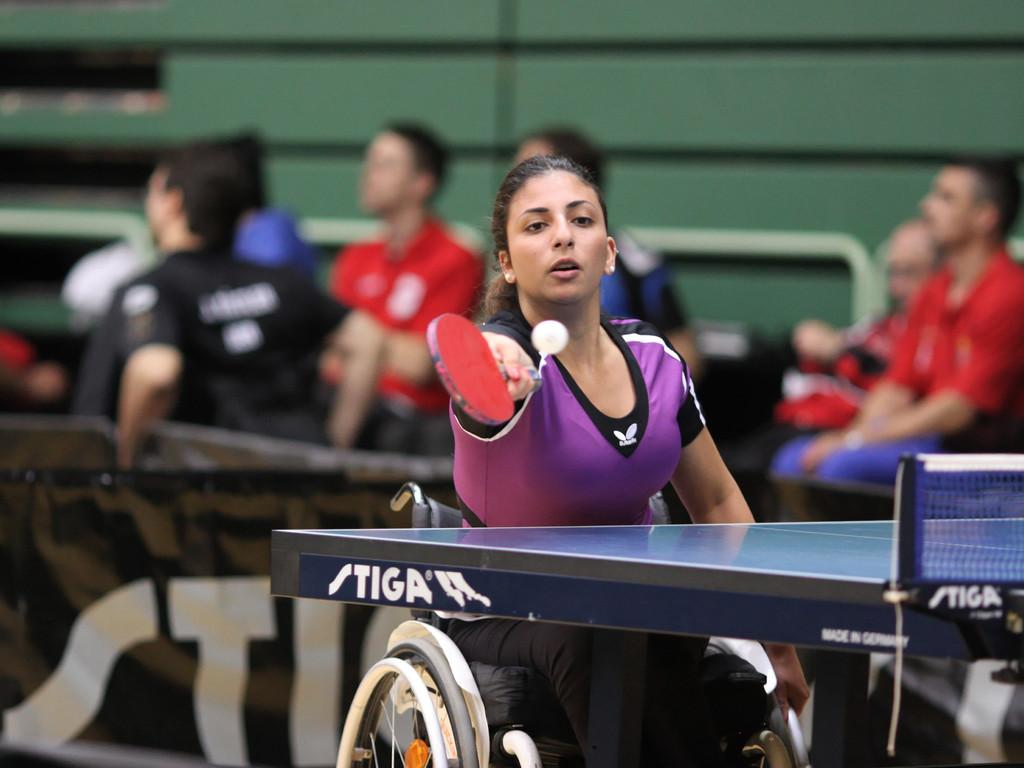Who is the main subject in the image? There is a woman in the image. What is the woman's position in the image? The woman is seated on a wheelchair. What activity is the woman engaged in? The woman is playing table tennis. Are there any other people present in the image? Yes, there are people seated on the side in the image. What type of veil is the woman wearing while playing table tennis? There is no veil present in the image; the woman is not wearing any head covering. 